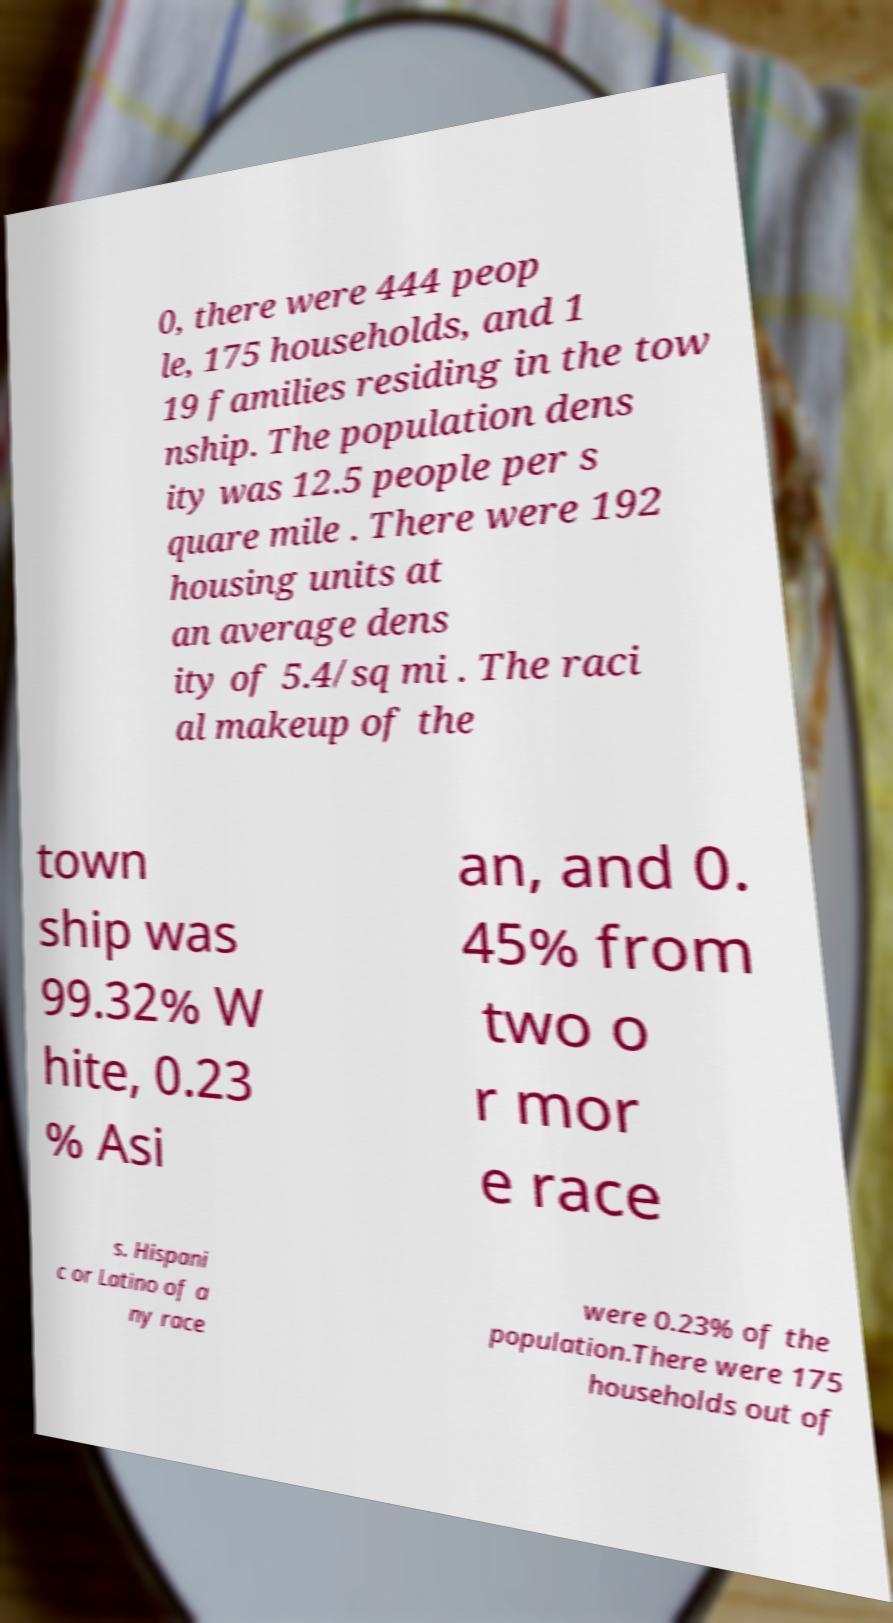There's text embedded in this image that I need extracted. Can you transcribe it verbatim? 0, there were 444 peop le, 175 households, and 1 19 families residing in the tow nship. The population dens ity was 12.5 people per s quare mile . There were 192 housing units at an average dens ity of 5.4/sq mi . The raci al makeup of the town ship was 99.32% W hite, 0.23 % Asi an, and 0. 45% from two o r mor e race s. Hispani c or Latino of a ny race were 0.23% of the population.There were 175 households out of 